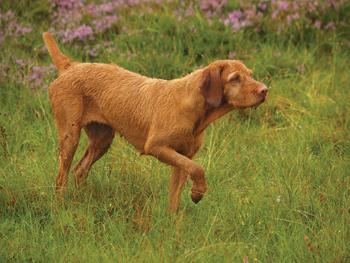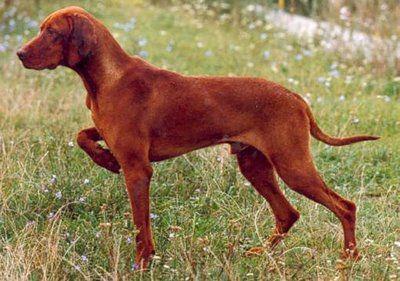The first image is the image on the left, the second image is the image on the right. Examine the images to the left and right. Is the description "The dog in the image on the right is standing with a front leg off the ground." accurate? Answer yes or no. Yes. The first image is the image on the left, the second image is the image on the right. Assess this claim about the two images: "The dogs in both images are holding one of their paws up off the ground.". Correct or not? Answer yes or no. Yes. 